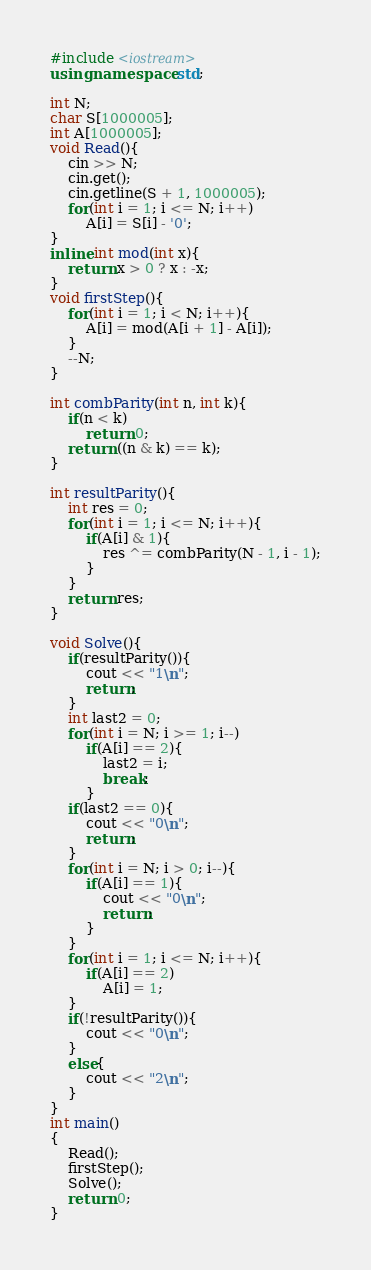<code> <loc_0><loc_0><loc_500><loc_500><_C++_>#include <iostream>
using namespace std;

int N;
char S[1000005];
int A[1000005];
void Read(){
    cin >> N;
    cin.get();
    cin.getline(S + 1, 1000005);
    for(int i = 1; i <= N; i++)
        A[i] = S[i] - '0';
}
inline int mod(int x){
    return x > 0 ? x : -x;
}
void firstStep(){
    for(int i = 1; i < N; i++){
        A[i] = mod(A[i + 1] - A[i]);
    }
    --N;
}

int combParity(int n, int k){
    if(n < k)
        return 0;
    return ((n & k) == k);
}

int resultParity(){
    int res = 0;
    for(int i = 1; i <= N; i++){
        if(A[i] & 1){
            res ^= combParity(N - 1, i - 1);
        }
    }
    return res;
}

void Solve(){
    if(resultParity()){
        cout << "1\n";
        return;
    }
    int last2 = 0;
    for(int i = N; i >= 1; i--)
        if(A[i] == 2){
            last2 = i;
            break;
        }
    if(last2 == 0){
        cout << "0\n";
        return;
    }
    for(int i = N; i > 0; i--){
        if(A[i] == 1){
            cout << "0\n";
            return;
        }
    }
    for(int i = 1; i <= N; i++){
        if(A[i] == 2)
            A[i] = 1;
    }
    if(!resultParity()){
        cout << "0\n";
    }
    else{
        cout << "2\n";
    }
}
int main()
{
    Read();
    firstStep();
    Solve();
    return 0;
}
</code> 